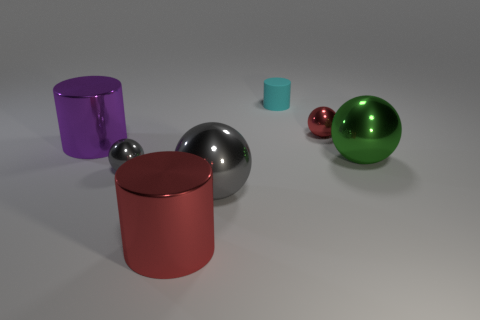Add 2 tiny things. How many objects exist? 9 Subtract all purple spheres. Subtract all gray cylinders. How many spheres are left? 4 Subtract all spheres. How many objects are left? 3 Add 6 large red things. How many large red things are left? 7 Add 2 large cylinders. How many large cylinders exist? 4 Subtract 0 brown spheres. How many objects are left? 7 Subtract all blue shiny blocks. Subtract all red shiny cylinders. How many objects are left? 6 